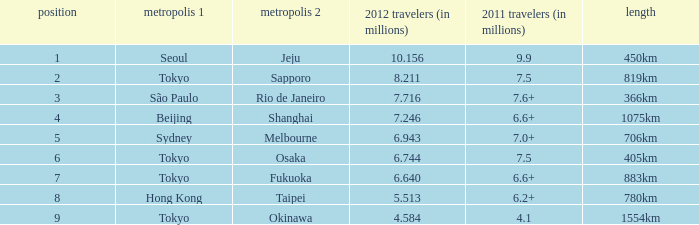In 2011, which city is listed first along the route that had 7.6+ million passengers? São Paulo. 